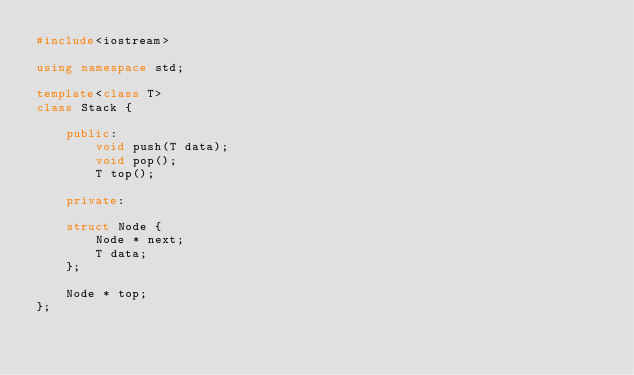<code> <loc_0><loc_0><loc_500><loc_500><_C++_>#include<iostream>

using namespace std;

template<class T>
class Stack {

	public:
		void push(T data);
		void pop();
		T top();

	private:

	struct Node {
		Node * next;
		T data;
	};

	Node * top;
};


</code> 